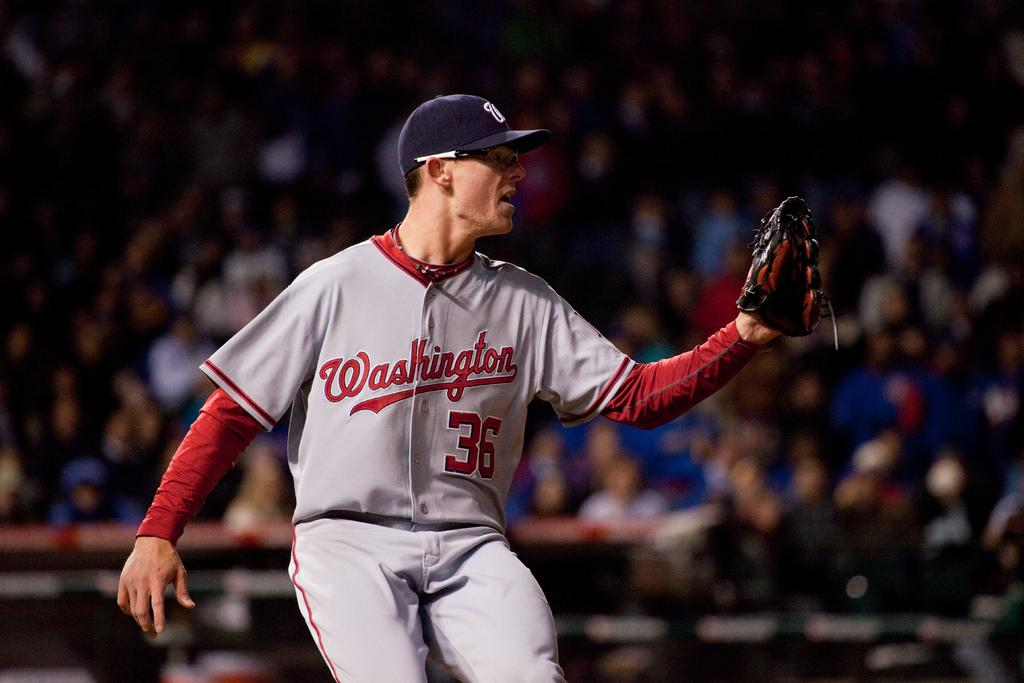<image>
Relay a brief, clear account of the picture shown. the city of Washington is on a jersey 